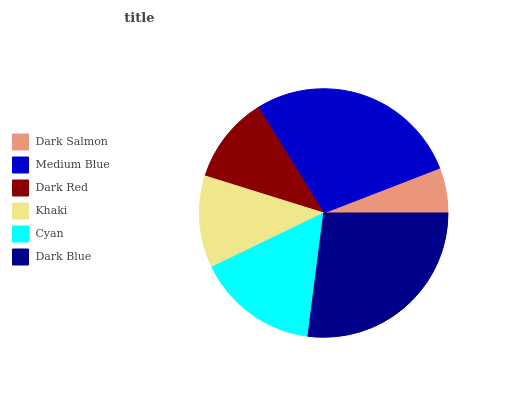Is Dark Salmon the minimum?
Answer yes or no. Yes. Is Medium Blue the maximum?
Answer yes or no. Yes. Is Dark Red the minimum?
Answer yes or no. No. Is Dark Red the maximum?
Answer yes or no. No. Is Medium Blue greater than Dark Red?
Answer yes or no. Yes. Is Dark Red less than Medium Blue?
Answer yes or no. Yes. Is Dark Red greater than Medium Blue?
Answer yes or no. No. Is Medium Blue less than Dark Red?
Answer yes or no. No. Is Cyan the high median?
Answer yes or no. Yes. Is Khaki the low median?
Answer yes or no. Yes. Is Khaki the high median?
Answer yes or no. No. Is Medium Blue the low median?
Answer yes or no. No. 